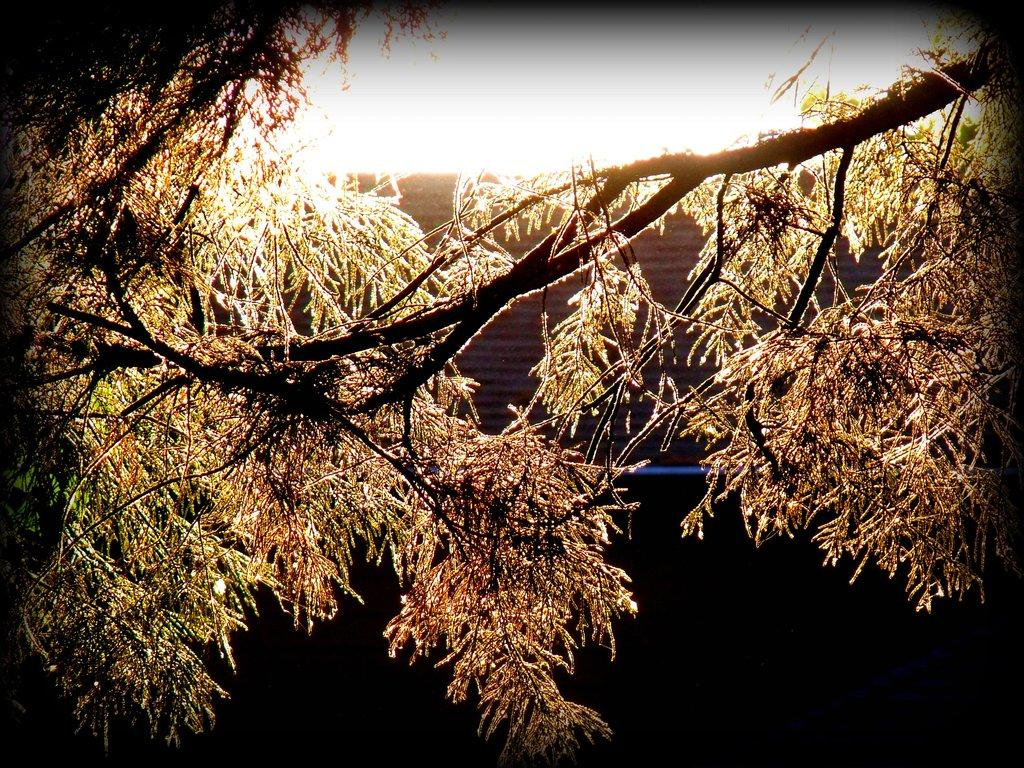What type of vegetation is visible in the image? There are leaves on the branches of a tree in the image. What type of print can be seen on the drawer in the image? There is no drawer present in the image; it only features a tree with leaves on its branches. What type of punishment is being administered in the image? There is no punishment being administered in the image; it only features a tree with leaves on its branches. 